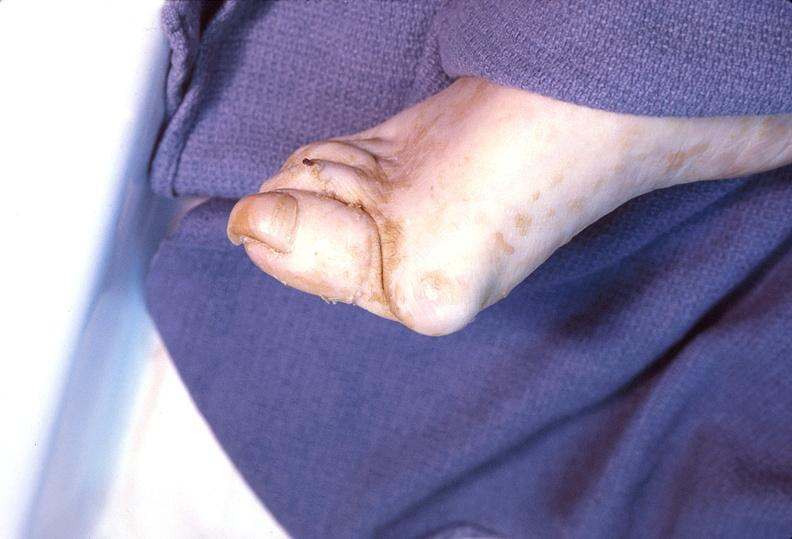what does this image show?
Answer the question using a single word or phrase. Foot 